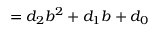Convert formula to latex. <formula><loc_0><loc_0><loc_500><loc_500>= d _ { 2 } b ^ { 2 } + d _ { 1 } b + d _ { 0 }</formula> 